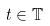<formula> <loc_0><loc_0><loc_500><loc_500>t \in \mathbb { T }</formula> 